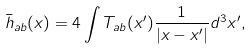<formula> <loc_0><loc_0><loc_500><loc_500>\bar { h } _ { a b } ( x ) = 4 \int T _ { a b } ( x ^ { \prime } ) \frac { 1 } { | x - x ^ { \prime } | } d ^ { 3 } x ^ { \prime } ,</formula> 